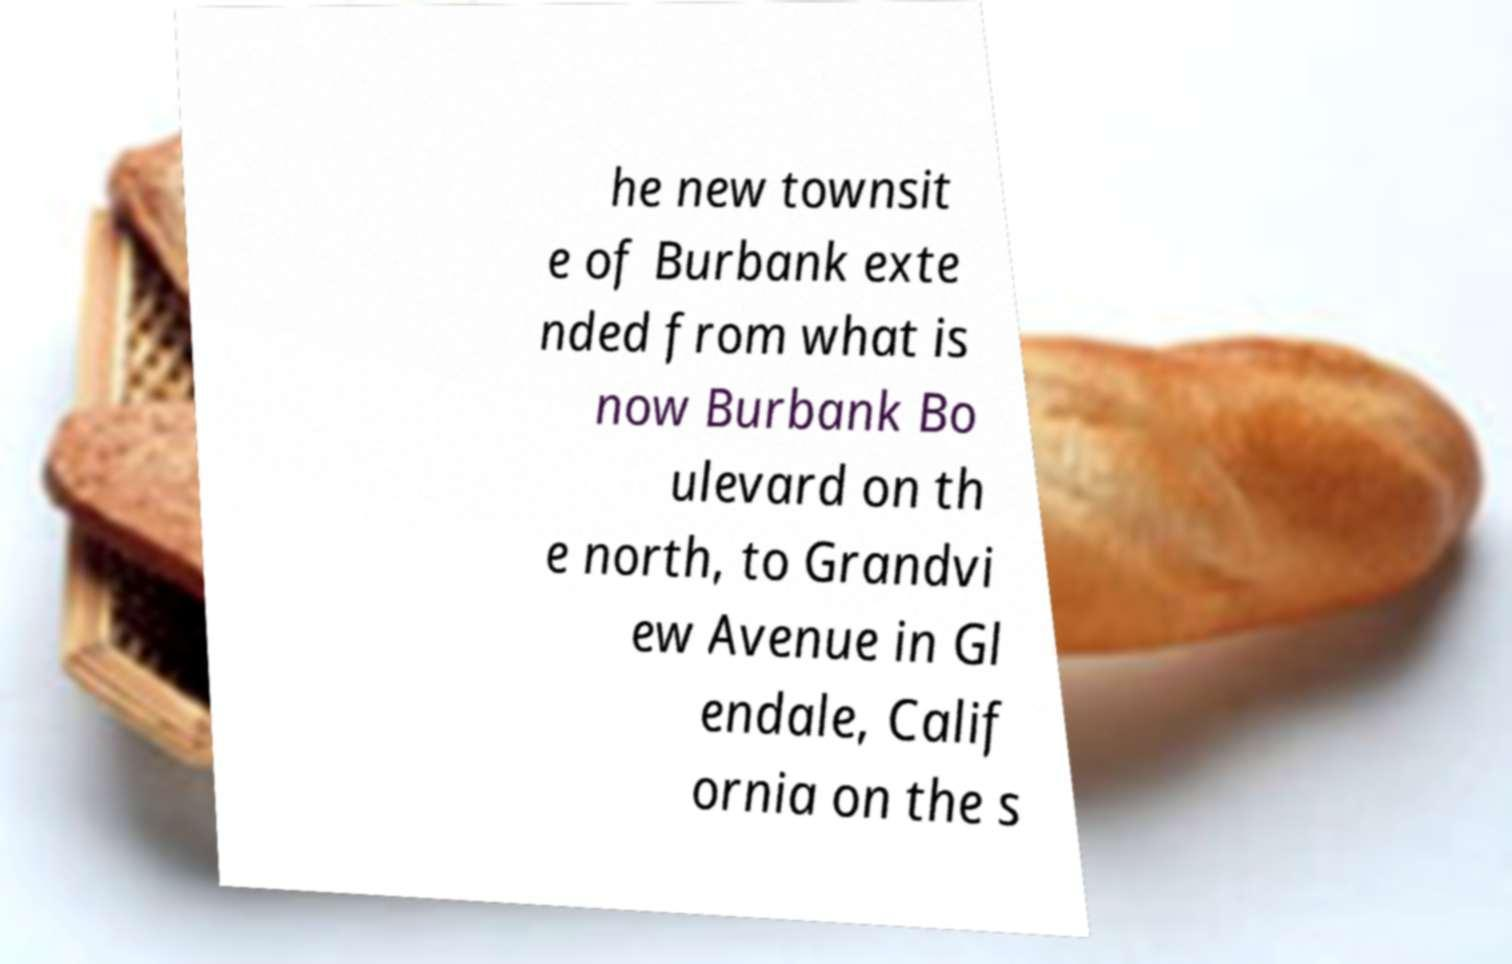What messages or text are displayed in this image? I need them in a readable, typed format. he new townsit e of Burbank exte nded from what is now Burbank Bo ulevard on th e north, to Grandvi ew Avenue in Gl endale, Calif ornia on the s 